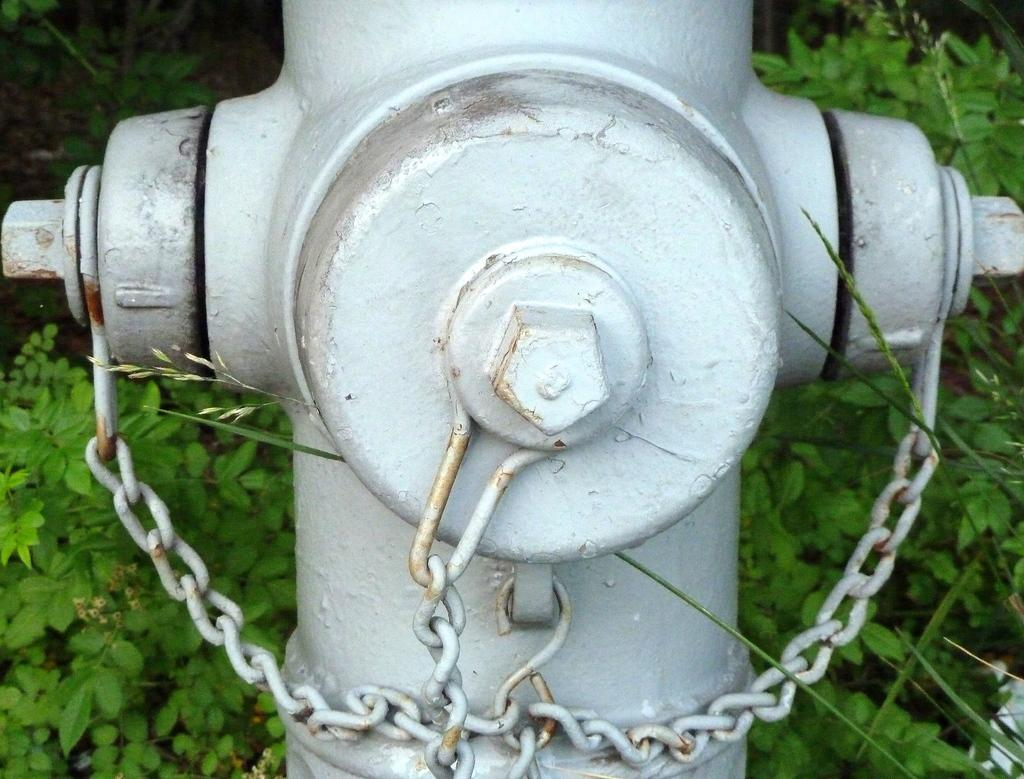What object can be seen in the image that is used for fire safety? There is a fire hydrant in the image. What is the chain used for in the image? The chain's purpose is not specified in the image, but it is visible. What type of vegetation can be seen in the image? There are leaves in the image. What type of bun is being served to the actor during the war in the image? There is no bun, actor, or war present in the image. 